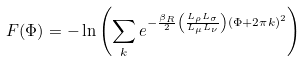Convert formula to latex. <formula><loc_0><loc_0><loc_500><loc_500>F ( \Phi ) = - \ln \left ( \sum _ { k } e ^ { - \frac { \beta _ { R } } { 2 } \left ( \frac { L _ { \rho } L _ { \sigma } } { L _ { \mu } L _ { \nu } } \right ) ( \Phi + 2 \pi k ) ^ { 2 } } \right )</formula> 